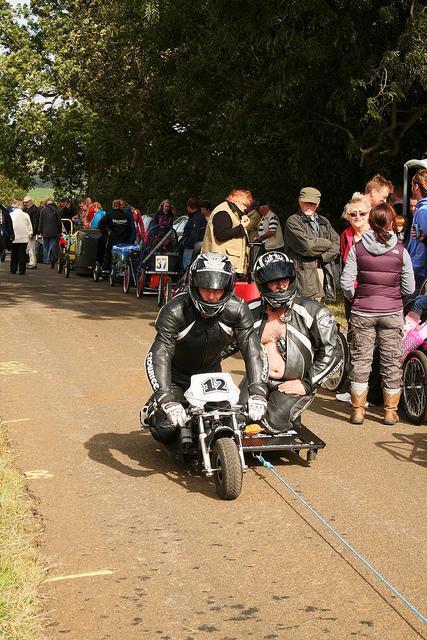How many men are riding the motorcycle?
Give a very brief answer. 2. How many people are in the picture?
Give a very brief answer. 6. 